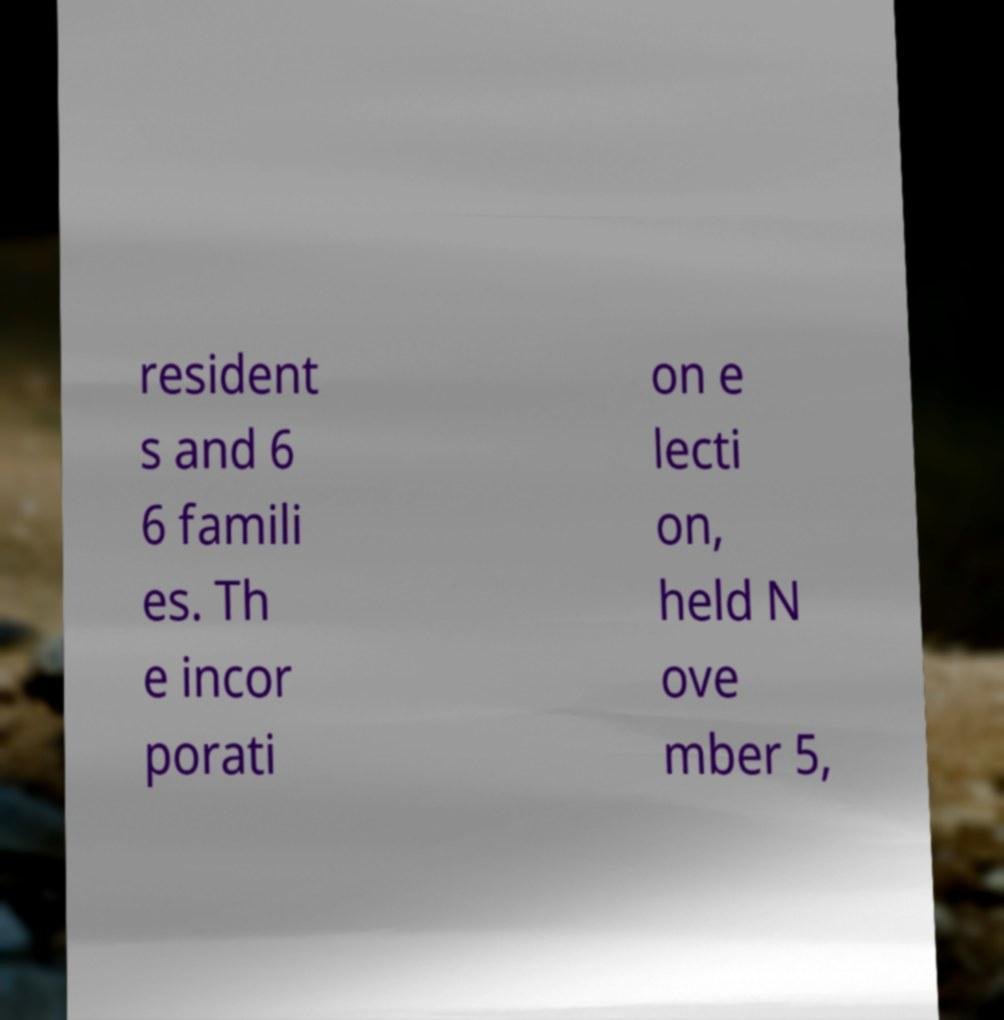For documentation purposes, I need the text within this image transcribed. Could you provide that? resident s and 6 6 famili es. Th e incor porati on e lecti on, held N ove mber 5, 